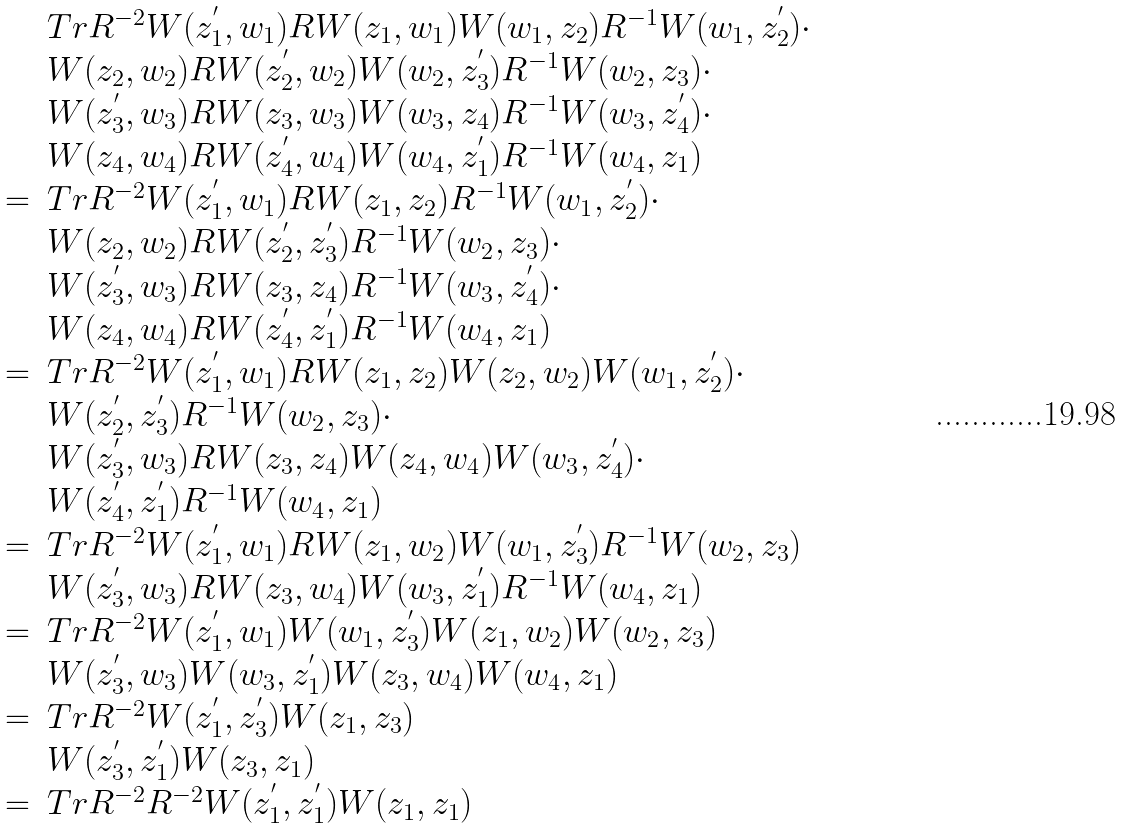Convert formula to latex. <formula><loc_0><loc_0><loc_500><loc_500>\begin{array} { r l } & T r R ^ { - 2 } W ( z _ { 1 } ^ { ^ { \prime } } , w _ { 1 } ) R W ( z _ { 1 } , w _ { 1 } ) W ( w _ { 1 } , z _ { 2 } ) R ^ { - 1 } W ( w _ { 1 } , z _ { 2 } ^ { ^ { \prime } } ) \cdot \\ & W ( z _ { 2 } , w _ { 2 } ) R W ( z _ { 2 } ^ { ^ { \prime } } , w _ { 2 } ) W ( w _ { 2 } , z _ { 3 } ^ { ^ { \prime } } ) R ^ { - 1 } W ( w _ { 2 } , z _ { 3 } ) \cdot \\ & W ( z _ { 3 } ^ { ^ { \prime } } , w _ { 3 } ) R W ( z _ { 3 } , w _ { 3 } ) W ( w _ { 3 } , z _ { 4 } ) R ^ { - 1 } W ( w _ { 3 } , z _ { 4 } ^ { ^ { \prime } } ) \cdot \\ & W ( z _ { 4 } , w _ { 4 } ) R W ( z _ { 4 } ^ { ^ { \prime } } , w _ { 4 } ) W ( w _ { 4 } , z _ { 1 } ^ { ^ { \prime } } ) R ^ { - 1 } W ( w _ { 4 } , z _ { 1 } ) \\ = & T r R ^ { - 2 } W ( z _ { 1 } ^ { ^ { \prime } } , w _ { 1 } ) R W ( z _ { 1 } , z _ { 2 } ) R ^ { - 1 } W ( w _ { 1 } , z _ { 2 } ^ { ^ { \prime } } ) \cdot \\ & W ( z _ { 2 } , w _ { 2 } ) R W ( z _ { 2 } ^ { ^ { \prime } } , z _ { 3 } ^ { ^ { \prime } } ) R ^ { - 1 } W ( w _ { 2 } , z _ { 3 } ) \cdot \\ & W ( z _ { 3 } ^ { ^ { \prime } } , w _ { 3 } ) R W ( z _ { 3 } , z _ { 4 } ) R ^ { - 1 } W ( w _ { 3 } , z _ { 4 } ^ { ^ { \prime } } ) \cdot \\ & W ( z _ { 4 } , w _ { 4 } ) R W ( z _ { 4 } ^ { ^ { \prime } } , z _ { 1 } ^ { ^ { \prime } } ) R ^ { - 1 } W ( w _ { 4 } , z _ { 1 } ) \\ = & T r R ^ { - 2 } W ( z _ { 1 } ^ { ^ { \prime } } , w _ { 1 } ) R W ( z _ { 1 } , z _ { 2 } ) W ( z _ { 2 } , w _ { 2 } ) W ( w _ { 1 } , z _ { 2 } ^ { ^ { \prime } } ) \cdot \\ & W ( z _ { 2 } ^ { ^ { \prime } } , z _ { 3 } ^ { ^ { \prime } } ) R ^ { - 1 } W ( w _ { 2 } , z _ { 3 } ) \cdot \\ & W ( z _ { 3 } ^ { ^ { \prime } } , w _ { 3 } ) R W ( z _ { 3 } , z _ { 4 } ) W ( z _ { 4 } , w _ { 4 } ) W ( w _ { 3 } , z _ { 4 } ^ { ^ { \prime } } ) \cdot \\ & W ( z _ { 4 } ^ { ^ { \prime } } , z _ { 1 } ^ { ^ { \prime } } ) R ^ { - 1 } W ( w _ { 4 } , z _ { 1 } ) \\ = & T r R ^ { - 2 } W ( z _ { 1 } ^ { ^ { \prime } } , w _ { 1 } ) R W ( z _ { 1 } , w _ { 2 } ) W ( w _ { 1 } , z _ { 3 } ^ { ^ { \prime } } ) R ^ { - 1 } W ( w _ { 2 } , z _ { 3 } ) \\ & W ( z _ { 3 } ^ { ^ { \prime } } , w _ { 3 } ) R W ( z _ { 3 } , w _ { 4 } ) W ( w _ { 3 } , z _ { 1 } ^ { ^ { \prime } } ) R ^ { - 1 } W ( w _ { 4 } , z _ { 1 } ) \\ = & T r R ^ { - 2 } W ( z _ { 1 } ^ { ^ { \prime } } , w _ { 1 } ) W ( w _ { 1 } , z _ { 3 } ^ { ^ { \prime } } ) W ( z _ { 1 } , w _ { 2 } ) W ( w _ { 2 } , z _ { 3 } ) \\ & W ( z _ { 3 } ^ { ^ { \prime } } , w _ { 3 } ) W ( w _ { 3 } , z _ { 1 } ^ { ^ { \prime } } ) W ( z _ { 3 } , w _ { 4 } ) W ( w _ { 4 } , z _ { 1 } ) \\ = & T r R ^ { - 2 } W ( z _ { 1 } ^ { ^ { \prime } } , z _ { 3 } ^ { ^ { \prime } } ) W ( z _ { 1 } , z _ { 3 } ) \\ & W ( z _ { 3 } ^ { ^ { \prime } } , z _ { 1 } ^ { ^ { \prime } } ) W ( z _ { 3 } , z _ { 1 } ) \\ = & T r R ^ { - 2 } R ^ { - 2 } W ( z _ { 1 } ^ { ^ { \prime } } , z _ { 1 } ^ { ^ { \prime } } ) W ( z _ { 1 } , z _ { 1 } ) \end{array}</formula> 